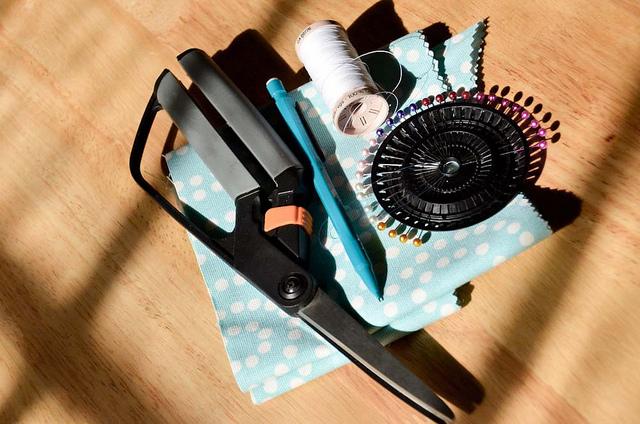What is the color of the material?
Write a very short answer. Blue. Does the thread match the fabric?
Quick response, please. Yes. Is the pin holder completely full?
Short answer required. No. 